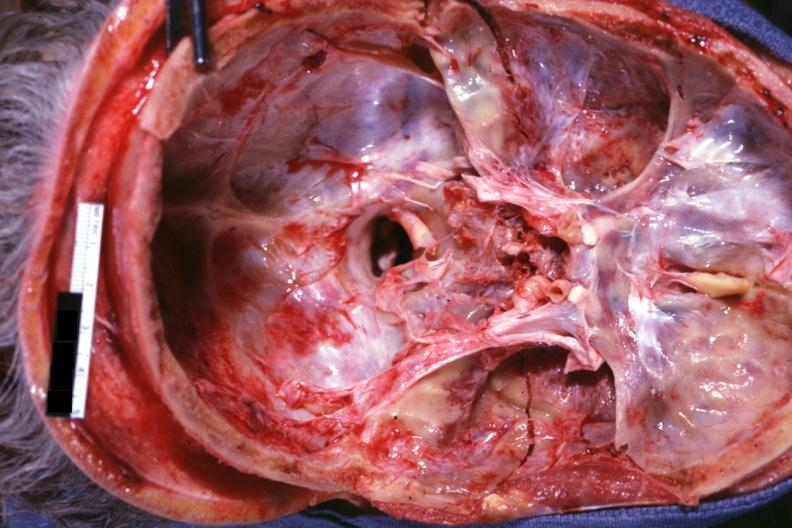s bone, calvarium present?
Answer the question using a single word or phrase. Yes 